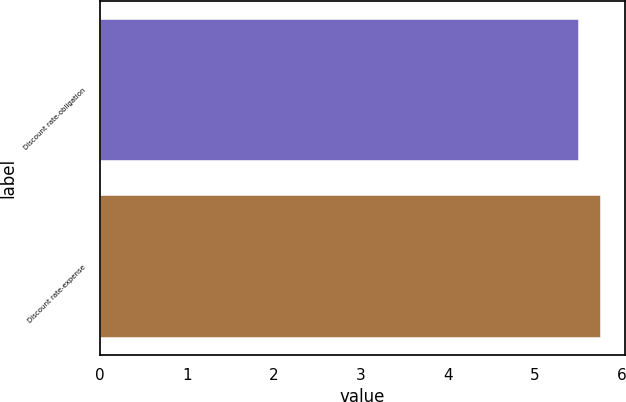Convert chart to OTSL. <chart><loc_0><loc_0><loc_500><loc_500><bar_chart><fcel>Discount rate-obligation<fcel>Discount rate-expense<nl><fcel>5.5<fcel>5.75<nl></chart> 